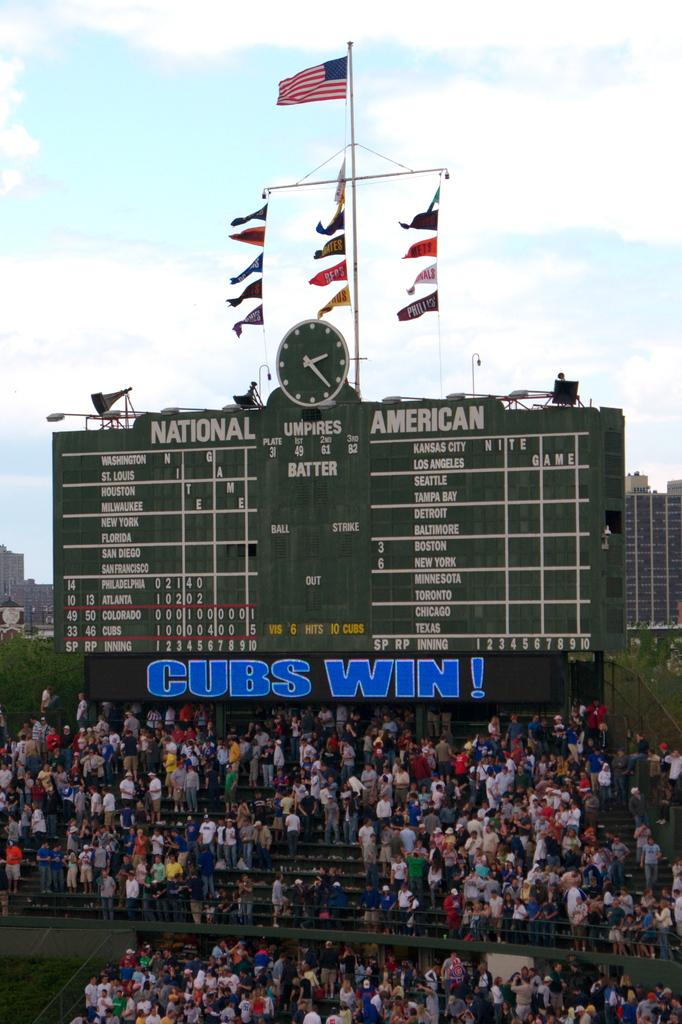Provide a one-sentence caption for the provided image. A game score board saying cubs win in blue on it. 